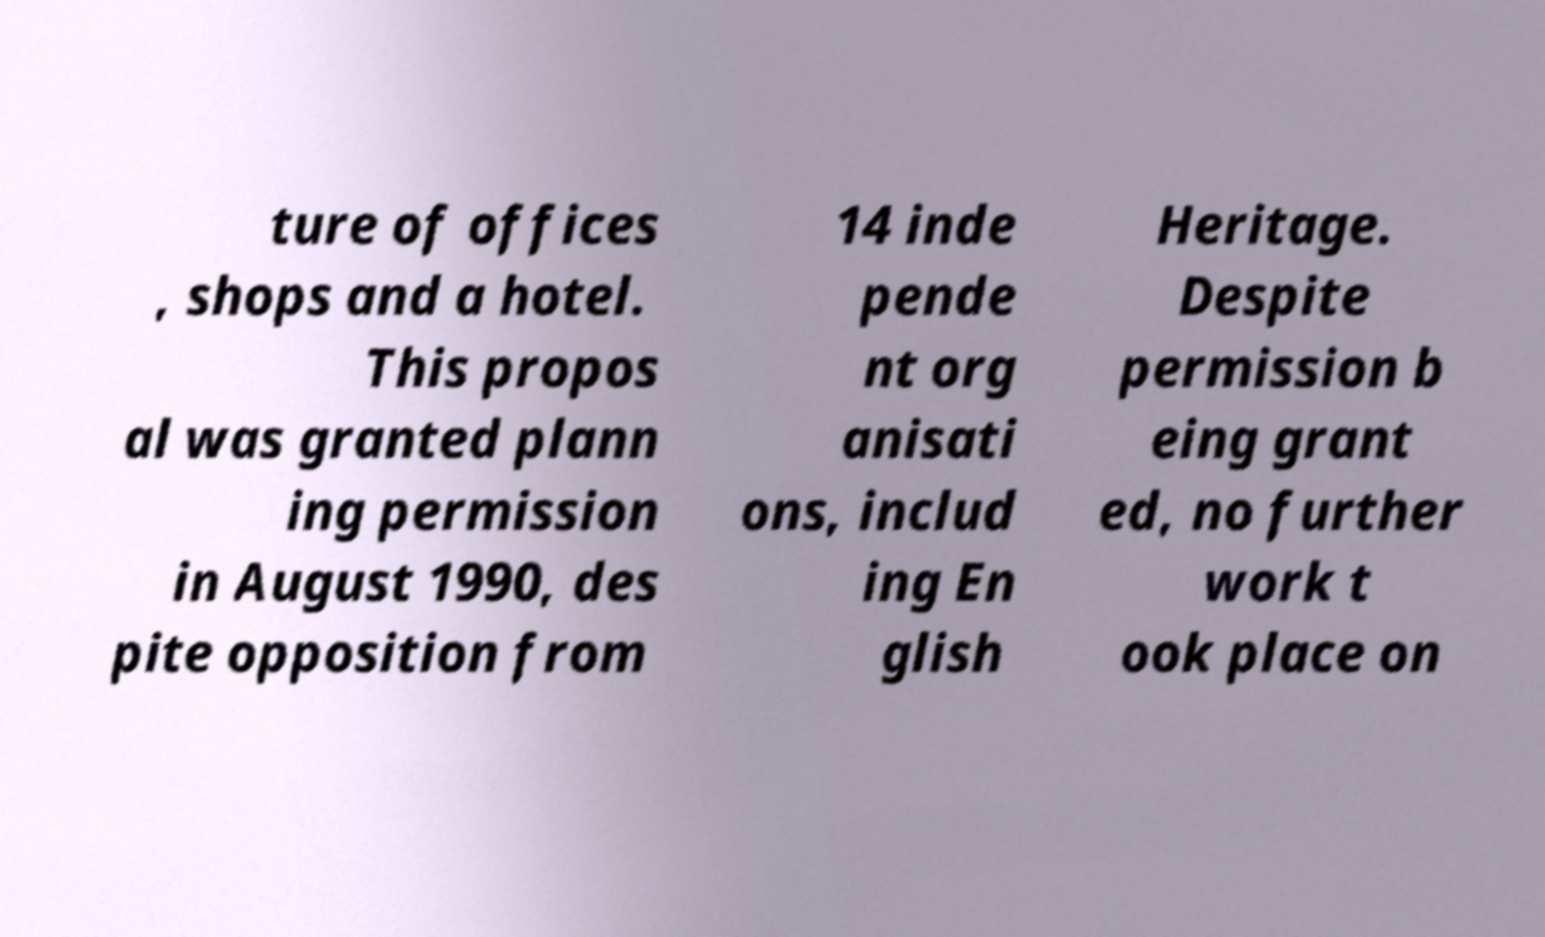Could you assist in decoding the text presented in this image and type it out clearly? ture of offices , shops and a hotel. This propos al was granted plann ing permission in August 1990, des pite opposition from 14 inde pende nt org anisati ons, includ ing En glish Heritage. Despite permission b eing grant ed, no further work t ook place on 